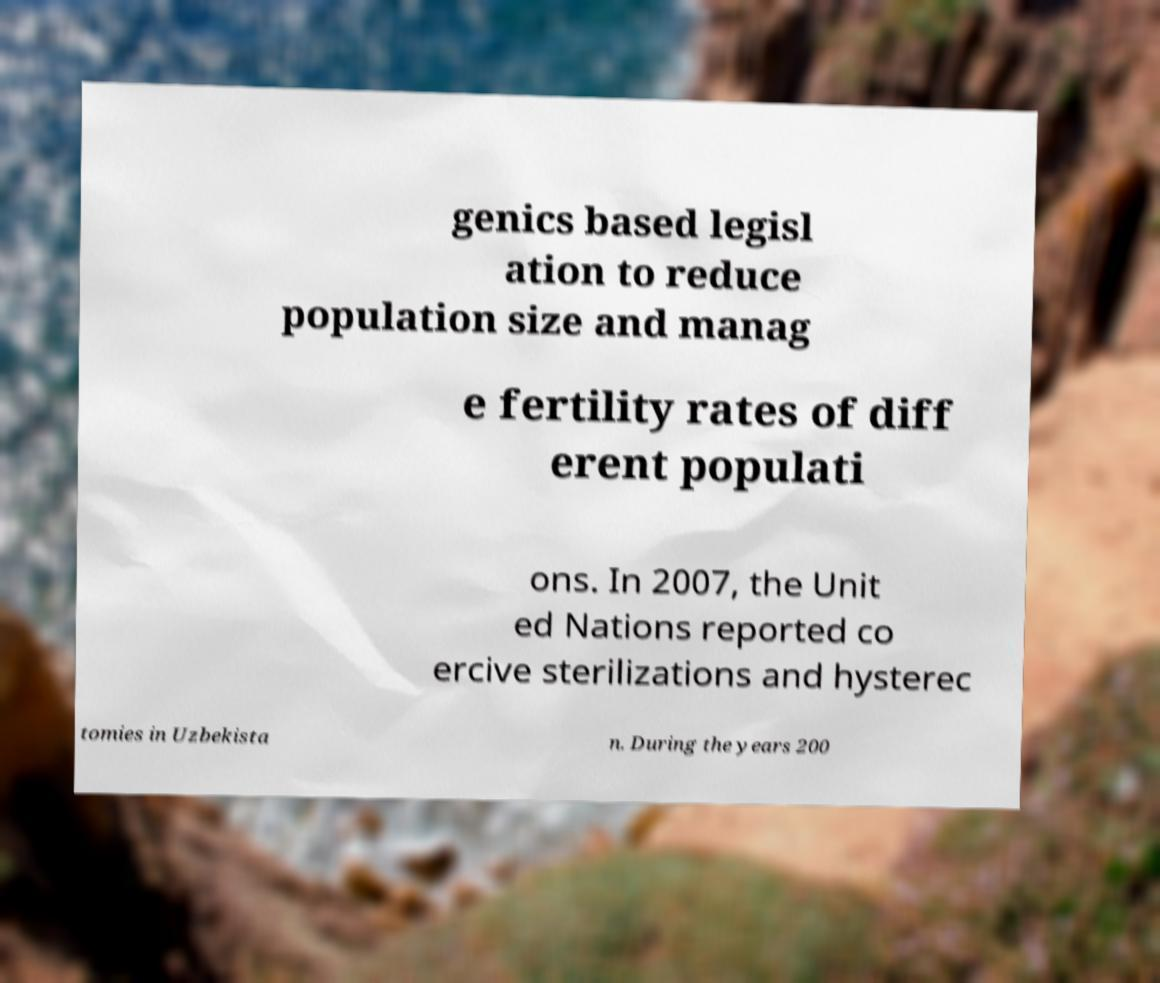What messages or text are displayed in this image? I need them in a readable, typed format. genics based legisl ation to reduce population size and manag e fertility rates of diff erent populati ons. In 2007, the Unit ed Nations reported co ercive sterilizations and hysterec tomies in Uzbekista n. During the years 200 